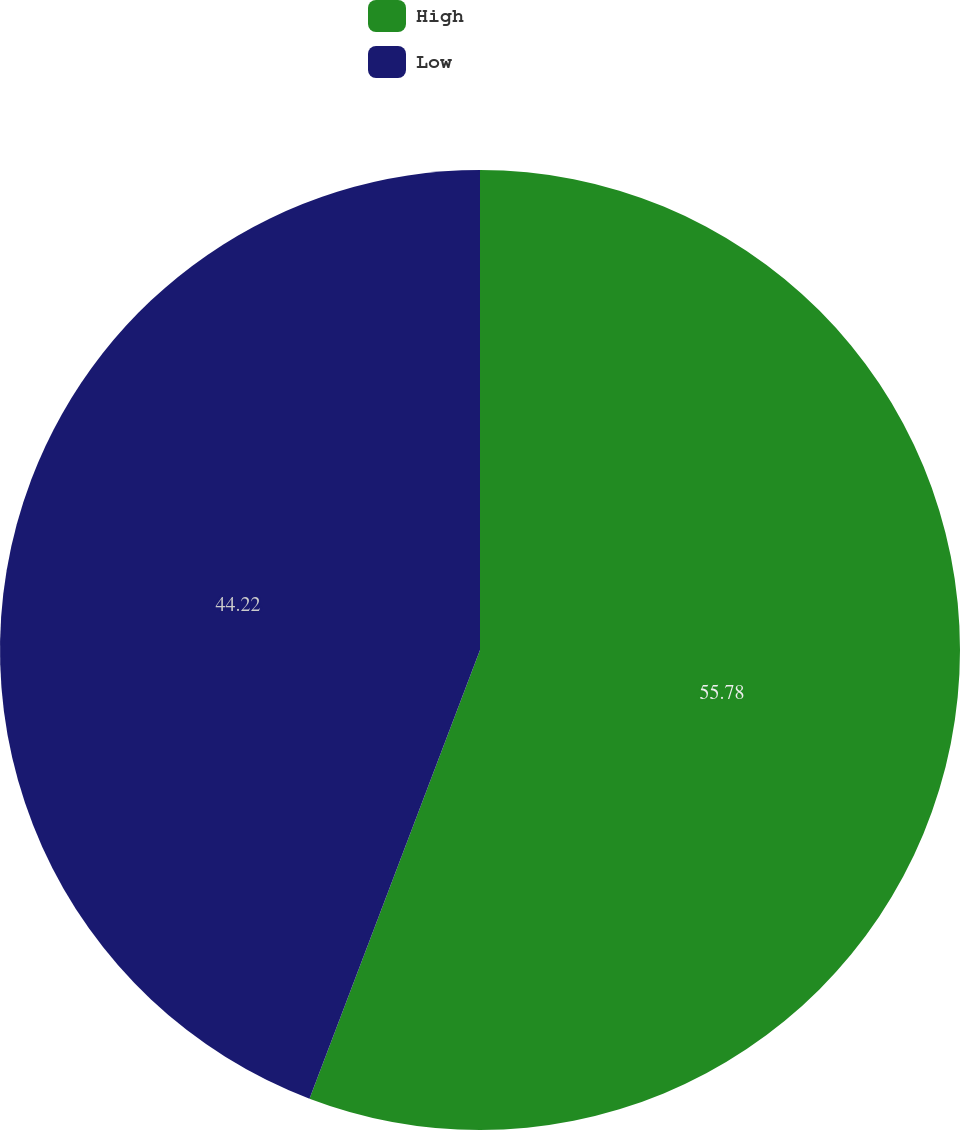Convert chart. <chart><loc_0><loc_0><loc_500><loc_500><pie_chart><fcel>High<fcel>Low<nl><fcel>55.78%<fcel>44.22%<nl></chart> 